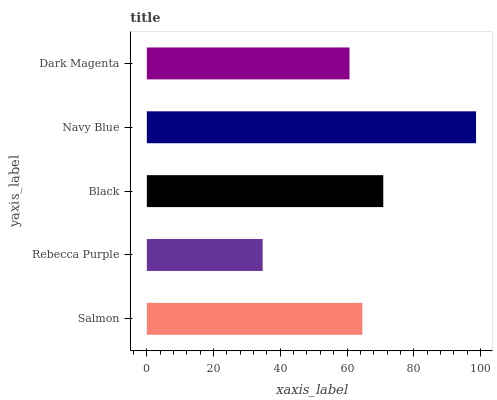Is Rebecca Purple the minimum?
Answer yes or no. Yes. Is Navy Blue the maximum?
Answer yes or no. Yes. Is Black the minimum?
Answer yes or no. No. Is Black the maximum?
Answer yes or no. No. Is Black greater than Rebecca Purple?
Answer yes or no. Yes. Is Rebecca Purple less than Black?
Answer yes or no. Yes. Is Rebecca Purple greater than Black?
Answer yes or no. No. Is Black less than Rebecca Purple?
Answer yes or no. No. Is Salmon the high median?
Answer yes or no. Yes. Is Salmon the low median?
Answer yes or no. Yes. Is Black the high median?
Answer yes or no. No. Is Black the low median?
Answer yes or no. No. 